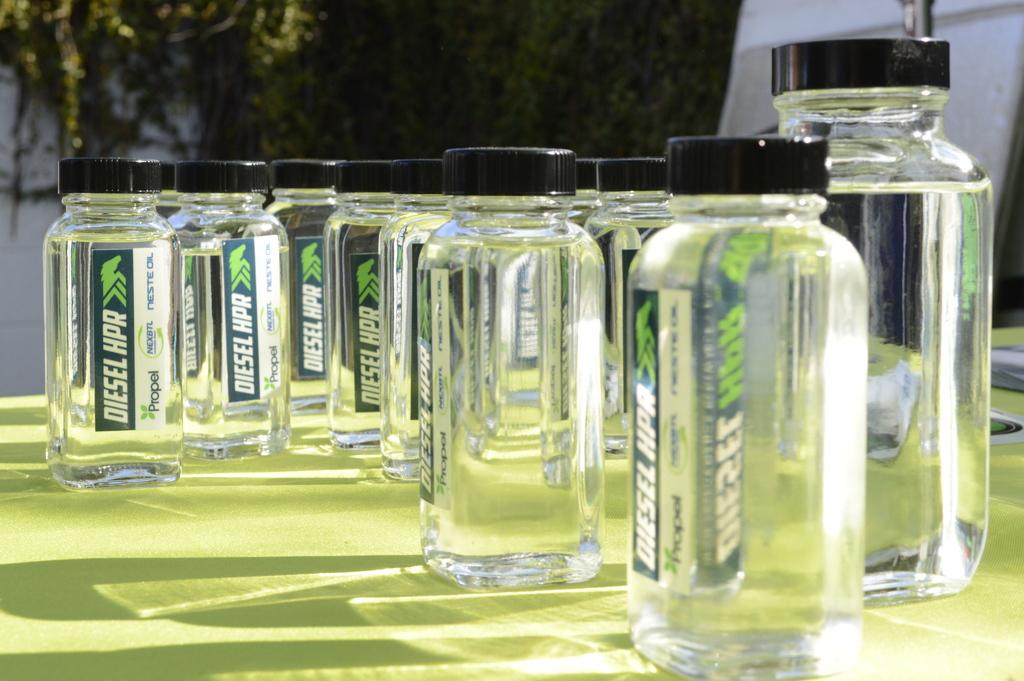Provide a one-sentence caption for the provided image. Several glass jars with Diesel hpr printed on them. 